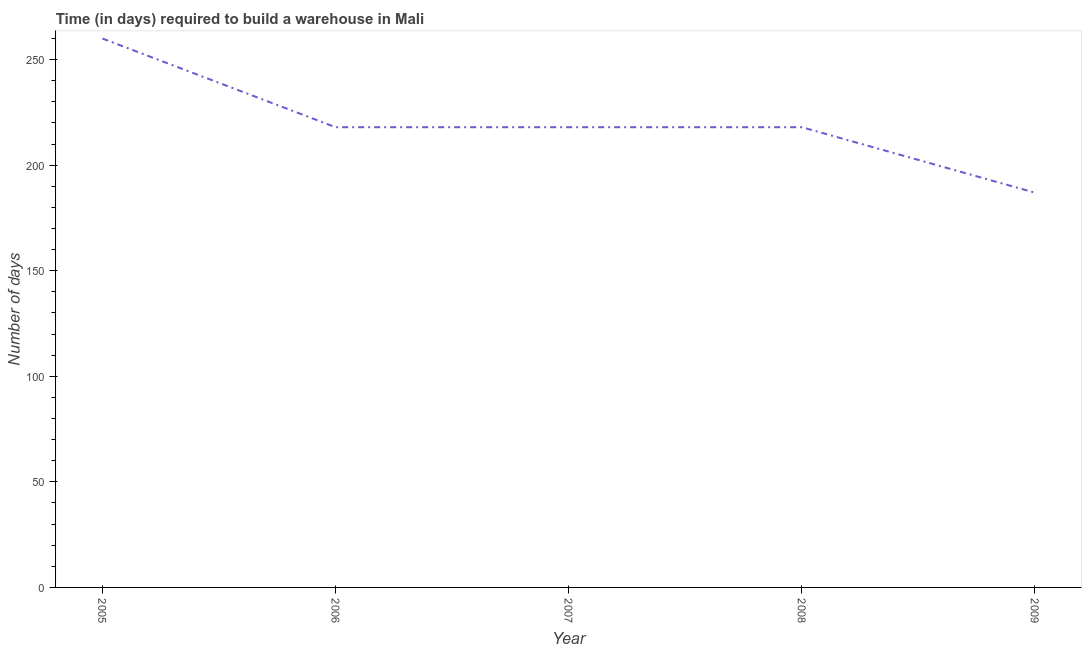What is the time required to build a warehouse in 2008?
Provide a succinct answer. 218. Across all years, what is the maximum time required to build a warehouse?
Offer a terse response. 260. Across all years, what is the minimum time required to build a warehouse?
Provide a short and direct response. 187. In which year was the time required to build a warehouse maximum?
Your answer should be very brief. 2005. What is the sum of the time required to build a warehouse?
Offer a terse response. 1101. What is the difference between the time required to build a warehouse in 2007 and 2009?
Your response must be concise. 31. What is the average time required to build a warehouse per year?
Make the answer very short. 220.2. What is the median time required to build a warehouse?
Provide a short and direct response. 218. In how many years, is the time required to build a warehouse greater than 160 days?
Keep it short and to the point. 5. What is the ratio of the time required to build a warehouse in 2005 to that in 2007?
Your response must be concise. 1.19. Is the time required to build a warehouse in 2006 less than that in 2009?
Keep it short and to the point. No. Is the sum of the time required to build a warehouse in 2005 and 2007 greater than the maximum time required to build a warehouse across all years?
Offer a terse response. Yes. What is the difference between the highest and the lowest time required to build a warehouse?
Make the answer very short. 73. How many years are there in the graph?
Your answer should be compact. 5. What is the title of the graph?
Ensure brevity in your answer.  Time (in days) required to build a warehouse in Mali. What is the label or title of the Y-axis?
Provide a succinct answer. Number of days. What is the Number of days of 2005?
Your answer should be compact. 260. What is the Number of days in 2006?
Your answer should be very brief. 218. What is the Number of days of 2007?
Keep it short and to the point. 218. What is the Number of days in 2008?
Provide a short and direct response. 218. What is the Number of days of 2009?
Offer a terse response. 187. What is the difference between the Number of days in 2005 and 2008?
Ensure brevity in your answer.  42. What is the difference between the Number of days in 2006 and 2007?
Provide a succinct answer. 0. What is the difference between the Number of days in 2006 and 2008?
Your answer should be compact. 0. What is the difference between the Number of days in 2007 and 2008?
Your answer should be very brief. 0. What is the ratio of the Number of days in 2005 to that in 2006?
Ensure brevity in your answer.  1.19. What is the ratio of the Number of days in 2005 to that in 2007?
Give a very brief answer. 1.19. What is the ratio of the Number of days in 2005 to that in 2008?
Keep it short and to the point. 1.19. What is the ratio of the Number of days in 2005 to that in 2009?
Your answer should be very brief. 1.39. What is the ratio of the Number of days in 2006 to that in 2007?
Offer a terse response. 1. What is the ratio of the Number of days in 2006 to that in 2008?
Offer a terse response. 1. What is the ratio of the Number of days in 2006 to that in 2009?
Your response must be concise. 1.17. What is the ratio of the Number of days in 2007 to that in 2009?
Provide a short and direct response. 1.17. What is the ratio of the Number of days in 2008 to that in 2009?
Your answer should be compact. 1.17. 